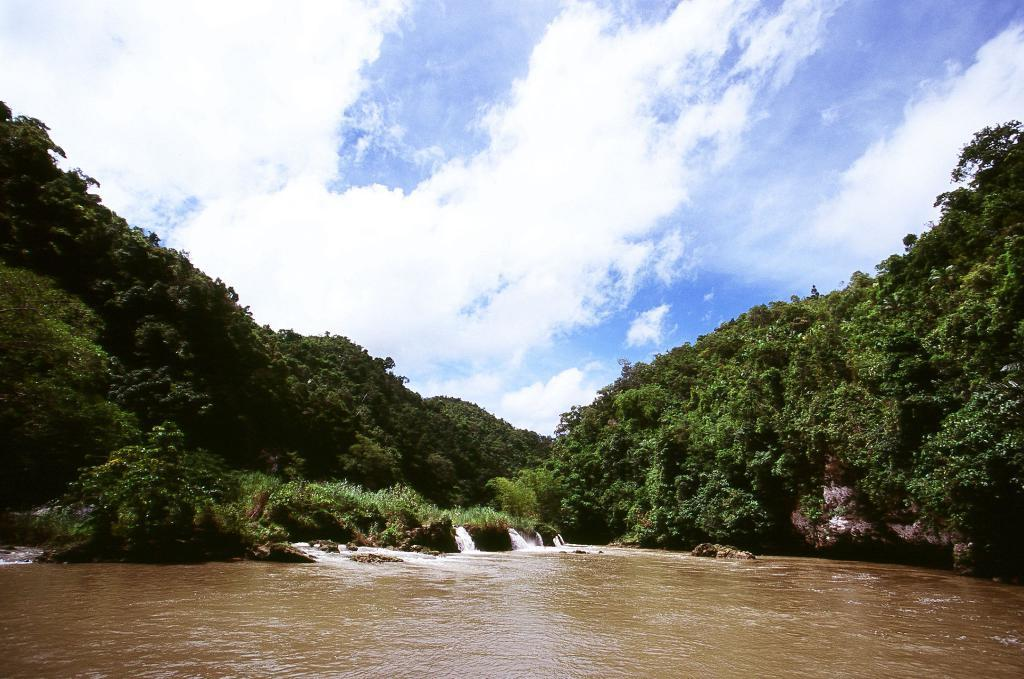What type of natural feature is at the bottom of the image? There is a river at the bottom of the image. What can be seen in the center of the image? There are trees in the center of the image. What is another water feature present in the image? There is a waterfall in the image. What is visible at the top of the image? The sky is visible at the top of the image. Where is the scarecrow located in the image? There is no scarecrow present in the image. What type of badge can be seen on the waterfall in the image? There are no badges present in the image, as it features natural elements like a river, trees, and a waterfall. 